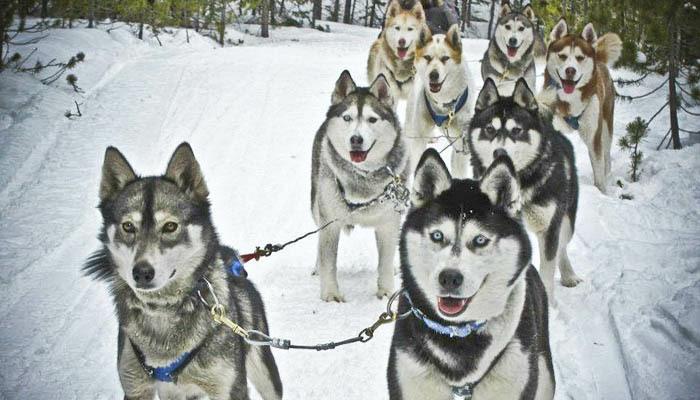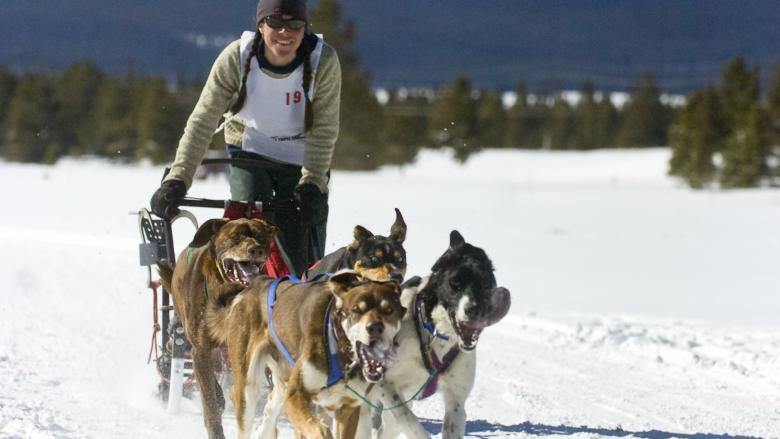The first image is the image on the left, the second image is the image on the right. For the images shown, is this caption "The lead dog sled teams in the left and right images head forward but are angled slightly away from each other so they would not collide." true? Answer yes or no. Yes. The first image is the image on the left, the second image is the image on the right. For the images displayed, is the sentence "There are two or more dog sled teams in the left image." factually correct? Answer yes or no. No. 